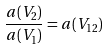Convert formula to latex. <formula><loc_0><loc_0><loc_500><loc_500>\frac { a ( V _ { 2 } ) } { a ( V _ { 1 } ) } = a ( V _ { 1 2 } )</formula> 